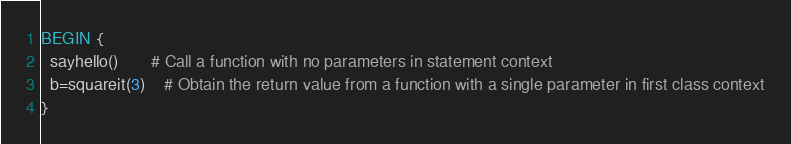Convert code to text. <code><loc_0><loc_0><loc_500><loc_500><_Awk_>BEGIN {
  sayhello()       # Call a function with no parameters in statement context
  b=squareit(3)    # Obtain the return value from a function with a single parameter in first class context
}
</code> 